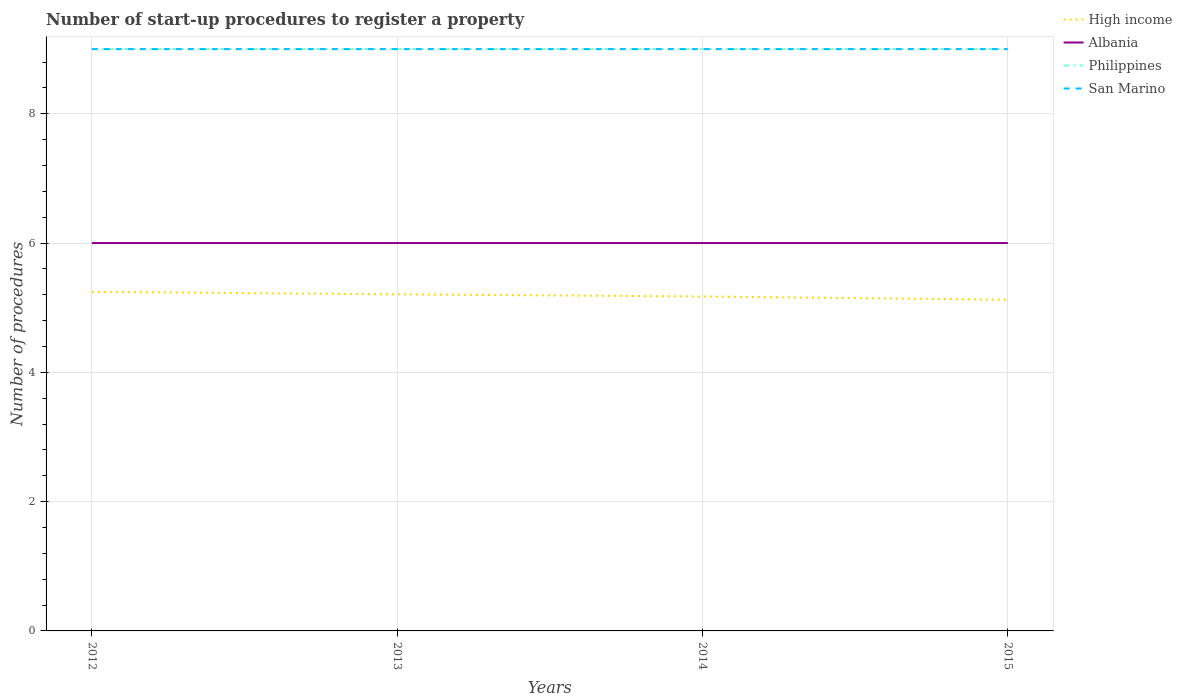How many different coloured lines are there?
Offer a terse response. 4. Does the line corresponding to High income intersect with the line corresponding to Philippines?
Your answer should be very brief. No. Is the number of lines equal to the number of legend labels?
Your answer should be compact. Yes. Across all years, what is the maximum number of procedures required to register a property in Philippines?
Your answer should be compact. 9. In which year was the number of procedures required to register a property in San Marino maximum?
Ensure brevity in your answer.  2012. What is the total number of procedures required to register a property in High income in the graph?
Offer a terse response. 0.08. What is the difference between the highest and the lowest number of procedures required to register a property in San Marino?
Provide a short and direct response. 0. How many years are there in the graph?
Ensure brevity in your answer.  4. How many legend labels are there?
Make the answer very short. 4. How are the legend labels stacked?
Your answer should be compact. Vertical. What is the title of the graph?
Your answer should be compact. Number of start-up procedures to register a property. Does "Nepal" appear as one of the legend labels in the graph?
Keep it short and to the point. No. What is the label or title of the Y-axis?
Ensure brevity in your answer.  Number of procedures. What is the Number of procedures in High income in 2012?
Your answer should be compact. 5.25. What is the Number of procedures of High income in 2013?
Provide a succinct answer. 5.21. What is the Number of procedures in San Marino in 2013?
Provide a succinct answer. 9. What is the Number of procedures of High income in 2014?
Provide a short and direct response. 5.17. What is the Number of procedures of Albania in 2014?
Give a very brief answer. 6. What is the Number of procedures in Philippines in 2014?
Provide a short and direct response. 9. What is the Number of procedures of San Marino in 2014?
Offer a terse response. 9. What is the Number of procedures of High income in 2015?
Keep it short and to the point. 5.12. What is the Number of procedures of Philippines in 2015?
Provide a succinct answer. 9. Across all years, what is the maximum Number of procedures of High income?
Make the answer very short. 5.25. Across all years, what is the maximum Number of procedures in Philippines?
Ensure brevity in your answer.  9. Across all years, what is the minimum Number of procedures of High income?
Ensure brevity in your answer.  5.12. Across all years, what is the minimum Number of procedures of San Marino?
Ensure brevity in your answer.  9. What is the total Number of procedures in High income in the graph?
Ensure brevity in your answer.  20.75. What is the total Number of procedures of Albania in the graph?
Your answer should be compact. 24. What is the total Number of procedures of San Marino in the graph?
Your response must be concise. 36. What is the difference between the Number of procedures of High income in 2012 and that in 2013?
Offer a very short reply. 0.04. What is the difference between the Number of procedures in Albania in 2012 and that in 2013?
Offer a terse response. 0. What is the difference between the Number of procedures of High income in 2012 and that in 2014?
Keep it short and to the point. 0.07. What is the difference between the Number of procedures of Albania in 2012 and that in 2014?
Ensure brevity in your answer.  0. What is the difference between the Number of procedures in Philippines in 2012 and that in 2014?
Make the answer very short. 0. What is the difference between the Number of procedures of San Marino in 2012 and that in 2014?
Your answer should be very brief. 0. What is the difference between the Number of procedures in High income in 2012 and that in 2015?
Your answer should be compact. 0.12. What is the difference between the Number of procedures in San Marino in 2012 and that in 2015?
Your answer should be compact. 0. What is the difference between the Number of procedures in Philippines in 2013 and that in 2014?
Offer a terse response. 0. What is the difference between the Number of procedures of High income in 2013 and that in 2015?
Give a very brief answer. 0.08. What is the difference between the Number of procedures in Albania in 2013 and that in 2015?
Make the answer very short. 0. What is the difference between the Number of procedures in Philippines in 2013 and that in 2015?
Offer a terse response. 0. What is the difference between the Number of procedures in San Marino in 2013 and that in 2015?
Offer a terse response. 0. What is the difference between the Number of procedures of Albania in 2014 and that in 2015?
Ensure brevity in your answer.  0. What is the difference between the Number of procedures in High income in 2012 and the Number of procedures in Albania in 2013?
Your answer should be very brief. -0.75. What is the difference between the Number of procedures of High income in 2012 and the Number of procedures of Philippines in 2013?
Your answer should be compact. -3.75. What is the difference between the Number of procedures of High income in 2012 and the Number of procedures of San Marino in 2013?
Give a very brief answer. -3.75. What is the difference between the Number of procedures in Albania in 2012 and the Number of procedures in Philippines in 2013?
Provide a short and direct response. -3. What is the difference between the Number of procedures in Albania in 2012 and the Number of procedures in San Marino in 2013?
Your answer should be compact. -3. What is the difference between the Number of procedures in Philippines in 2012 and the Number of procedures in San Marino in 2013?
Offer a very short reply. 0. What is the difference between the Number of procedures of High income in 2012 and the Number of procedures of Albania in 2014?
Keep it short and to the point. -0.75. What is the difference between the Number of procedures in High income in 2012 and the Number of procedures in Philippines in 2014?
Offer a terse response. -3.75. What is the difference between the Number of procedures in High income in 2012 and the Number of procedures in San Marino in 2014?
Offer a terse response. -3.75. What is the difference between the Number of procedures in Albania in 2012 and the Number of procedures in Philippines in 2014?
Offer a very short reply. -3. What is the difference between the Number of procedures in Albania in 2012 and the Number of procedures in San Marino in 2014?
Provide a succinct answer. -3. What is the difference between the Number of procedures of Philippines in 2012 and the Number of procedures of San Marino in 2014?
Provide a short and direct response. 0. What is the difference between the Number of procedures of High income in 2012 and the Number of procedures of Albania in 2015?
Your answer should be compact. -0.75. What is the difference between the Number of procedures in High income in 2012 and the Number of procedures in Philippines in 2015?
Your answer should be very brief. -3.75. What is the difference between the Number of procedures in High income in 2012 and the Number of procedures in San Marino in 2015?
Make the answer very short. -3.75. What is the difference between the Number of procedures in Albania in 2012 and the Number of procedures in San Marino in 2015?
Make the answer very short. -3. What is the difference between the Number of procedures in Philippines in 2012 and the Number of procedures in San Marino in 2015?
Provide a short and direct response. 0. What is the difference between the Number of procedures of High income in 2013 and the Number of procedures of Albania in 2014?
Offer a terse response. -0.79. What is the difference between the Number of procedures of High income in 2013 and the Number of procedures of Philippines in 2014?
Offer a very short reply. -3.79. What is the difference between the Number of procedures of High income in 2013 and the Number of procedures of San Marino in 2014?
Offer a terse response. -3.79. What is the difference between the Number of procedures of Albania in 2013 and the Number of procedures of San Marino in 2014?
Provide a short and direct response. -3. What is the difference between the Number of procedures of Philippines in 2013 and the Number of procedures of San Marino in 2014?
Provide a succinct answer. 0. What is the difference between the Number of procedures of High income in 2013 and the Number of procedures of Albania in 2015?
Offer a terse response. -0.79. What is the difference between the Number of procedures in High income in 2013 and the Number of procedures in Philippines in 2015?
Ensure brevity in your answer.  -3.79. What is the difference between the Number of procedures in High income in 2013 and the Number of procedures in San Marino in 2015?
Keep it short and to the point. -3.79. What is the difference between the Number of procedures in High income in 2014 and the Number of procedures in Albania in 2015?
Keep it short and to the point. -0.83. What is the difference between the Number of procedures of High income in 2014 and the Number of procedures of Philippines in 2015?
Ensure brevity in your answer.  -3.83. What is the difference between the Number of procedures in High income in 2014 and the Number of procedures in San Marino in 2015?
Your answer should be compact. -3.83. What is the difference between the Number of procedures in Albania in 2014 and the Number of procedures in Philippines in 2015?
Offer a very short reply. -3. What is the average Number of procedures of High income per year?
Ensure brevity in your answer.  5.19. What is the average Number of procedures in Albania per year?
Ensure brevity in your answer.  6. What is the average Number of procedures of Philippines per year?
Give a very brief answer. 9. What is the average Number of procedures of San Marino per year?
Provide a succinct answer. 9. In the year 2012, what is the difference between the Number of procedures in High income and Number of procedures in Albania?
Provide a succinct answer. -0.75. In the year 2012, what is the difference between the Number of procedures in High income and Number of procedures in Philippines?
Offer a very short reply. -3.75. In the year 2012, what is the difference between the Number of procedures in High income and Number of procedures in San Marino?
Keep it short and to the point. -3.75. In the year 2012, what is the difference between the Number of procedures in Albania and Number of procedures in Philippines?
Your answer should be compact. -3. In the year 2012, what is the difference between the Number of procedures in Albania and Number of procedures in San Marino?
Your answer should be very brief. -3. In the year 2012, what is the difference between the Number of procedures of Philippines and Number of procedures of San Marino?
Make the answer very short. 0. In the year 2013, what is the difference between the Number of procedures of High income and Number of procedures of Albania?
Give a very brief answer. -0.79. In the year 2013, what is the difference between the Number of procedures in High income and Number of procedures in Philippines?
Your answer should be compact. -3.79. In the year 2013, what is the difference between the Number of procedures in High income and Number of procedures in San Marino?
Provide a succinct answer. -3.79. In the year 2014, what is the difference between the Number of procedures in High income and Number of procedures in Albania?
Ensure brevity in your answer.  -0.83. In the year 2014, what is the difference between the Number of procedures of High income and Number of procedures of Philippines?
Your answer should be compact. -3.83. In the year 2014, what is the difference between the Number of procedures of High income and Number of procedures of San Marino?
Ensure brevity in your answer.  -3.83. In the year 2015, what is the difference between the Number of procedures in High income and Number of procedures in Albania?
Make the answer very short. -0.88. In the year 2015, what is the difference between the Number of procedures in High income and Number of procedures in Philippines?
Provide a short and direct response. -3.88. In the year 2015, what is the difference between the Number of procedures of High income and Number of procedures of San Marino?
Your response must be concise. -3.88. In the year 2015, what is the difference between the Number of procedures in Albania and Number of procedures in Philippines?
Keep it short and to the point. -3. In the year 2015, what is the difference between the Number of procedures of Albania and Number of procedures of San Marino?
Provide a short and direct response. -3. What is the ratio of the Number of procedures in High income in 2012 to that in 2013?
Provide a succinct answer. 1.01. What is the ratio of the Number of procedures of Albania in 2012 to that in 2013?
Make the answer very short. 1. What is the ratio of the Number of procedures of Philippines in 2012 to that in 2013?
Your answer should be compact. 1. What is the ratio of the Number of procedures in San Marino in 2012 to that in 2013?
Provide a short and direct response. 1. What is the ratio of the Number of procedures of High income in 2012 to that in 2014?
Provide a succinct answer. 1.01. What is the ratio of the Number of procedures in Philippines in 2012 to that in 2014?
Provide a short and direct response. 1. What is the ratio of the Number of procedures in San Marino in 2012 to that in 2014?
Provide a short and direct response. 1. What is the ratio of the Number of procedures of High income in 2012 to that in 2015?
Ensure brevity in your answer.  1.02. What is the ratio of the Number of procedures of Philippines in 2012 to that in 2015?
Give a very brief answer. 1. What is the ratio of the Number of procedures in High income in 2013 to that in 2014?
Make the answer very short. 1.01. What is the ratio of the Number of procedures in High income in 2013 to that in 2015?
Offer a very short reply. 1.02. What is the ratio of the Number of procedures of San Marino in 2013 to that in 2015?
Your answer should be compact. 1. What is the ratio of the Number of procedures of High income in 2014 to that in 2015?
Give a very brief answer. 1.01. What is the ratio of the Number of procedures in San Marino in 2014 to that in 2015?
Offer a very short reply. 1. What is the difference between the highest and the second highest Number of procedures of High income?
Your response must be concise. 0.04. What is the difference between the highest and the second highest Number of procedures of Albania?
Give a very brief answer. 0. What is the difference between the highest and the second highest Number of procedures of San Marino?
Ensure brevity in your answer.  0. What is the difference between the highest and the lowest Number of procedures in High income?
Give a very brief answer. 0.12. 